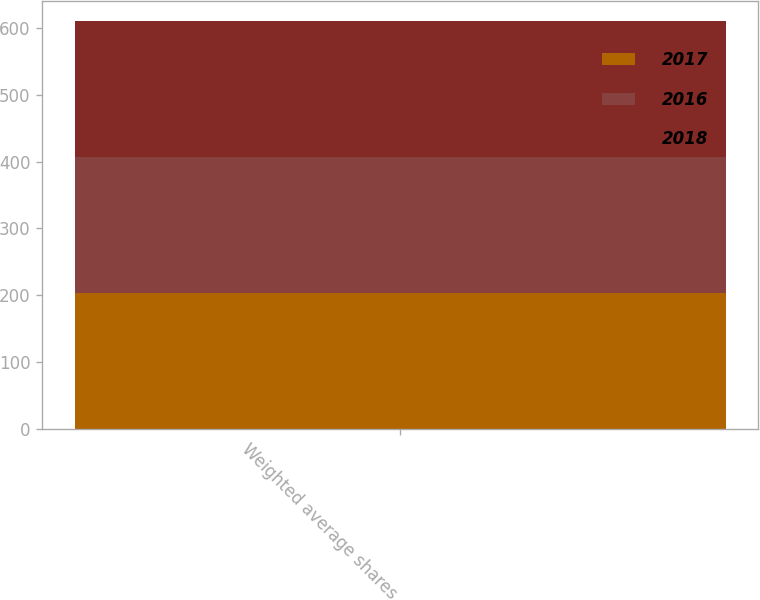<chart> <loc_0><loc_0><loc_500><loc_500><stacked_bar_chart><ecel><fcel>Weighted average shares<nl><fcel>2017<fcel>203.5<nl><fcel>2016<fcel>203.7<nl><fcel>2018<fcel>202.4<nl></chart> 